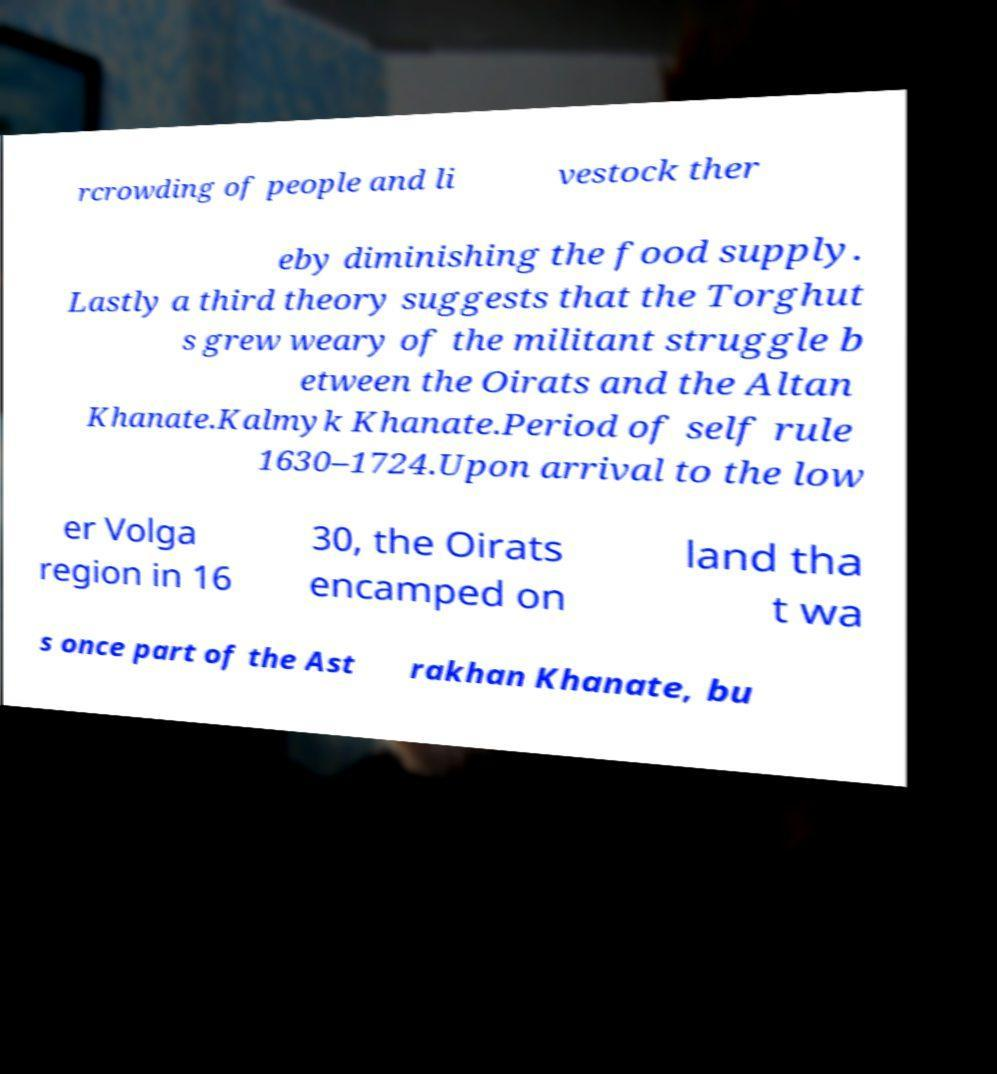Can you accurately transcribe the text from the provided image for me? rcrowding of people and li vestock ther eby diminishing the food supply. Lastly a third theory suggests that the Torghut s grew weary of the militant struggle b etween the Oirats and the Altan Khanate.Kalmyk Khanate.Period of self rule 1630–1724.Upon arrival to the low er Volga region in 16 30, the Oirats encamped on land tha t wa s once part of the Ast rakhan Khanate, bu 